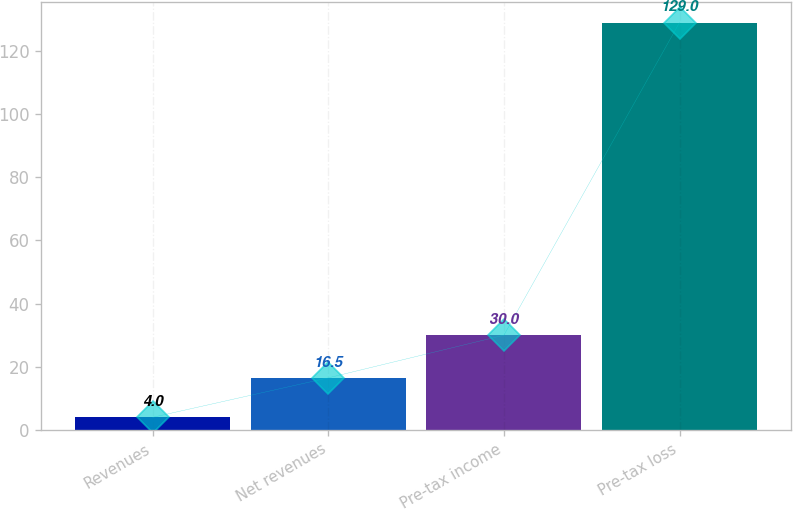Convert chart. <chart><loc_0><loc_0><loc_500><loc_500><bar_chart><fcel>Revenues<fcel>Net revenues<fcel>Pre-tax income<fcel>Pre-tax loss<nl><fcel>4<fcel>16.5<fcel>30<fcel>129<nl></chart> 